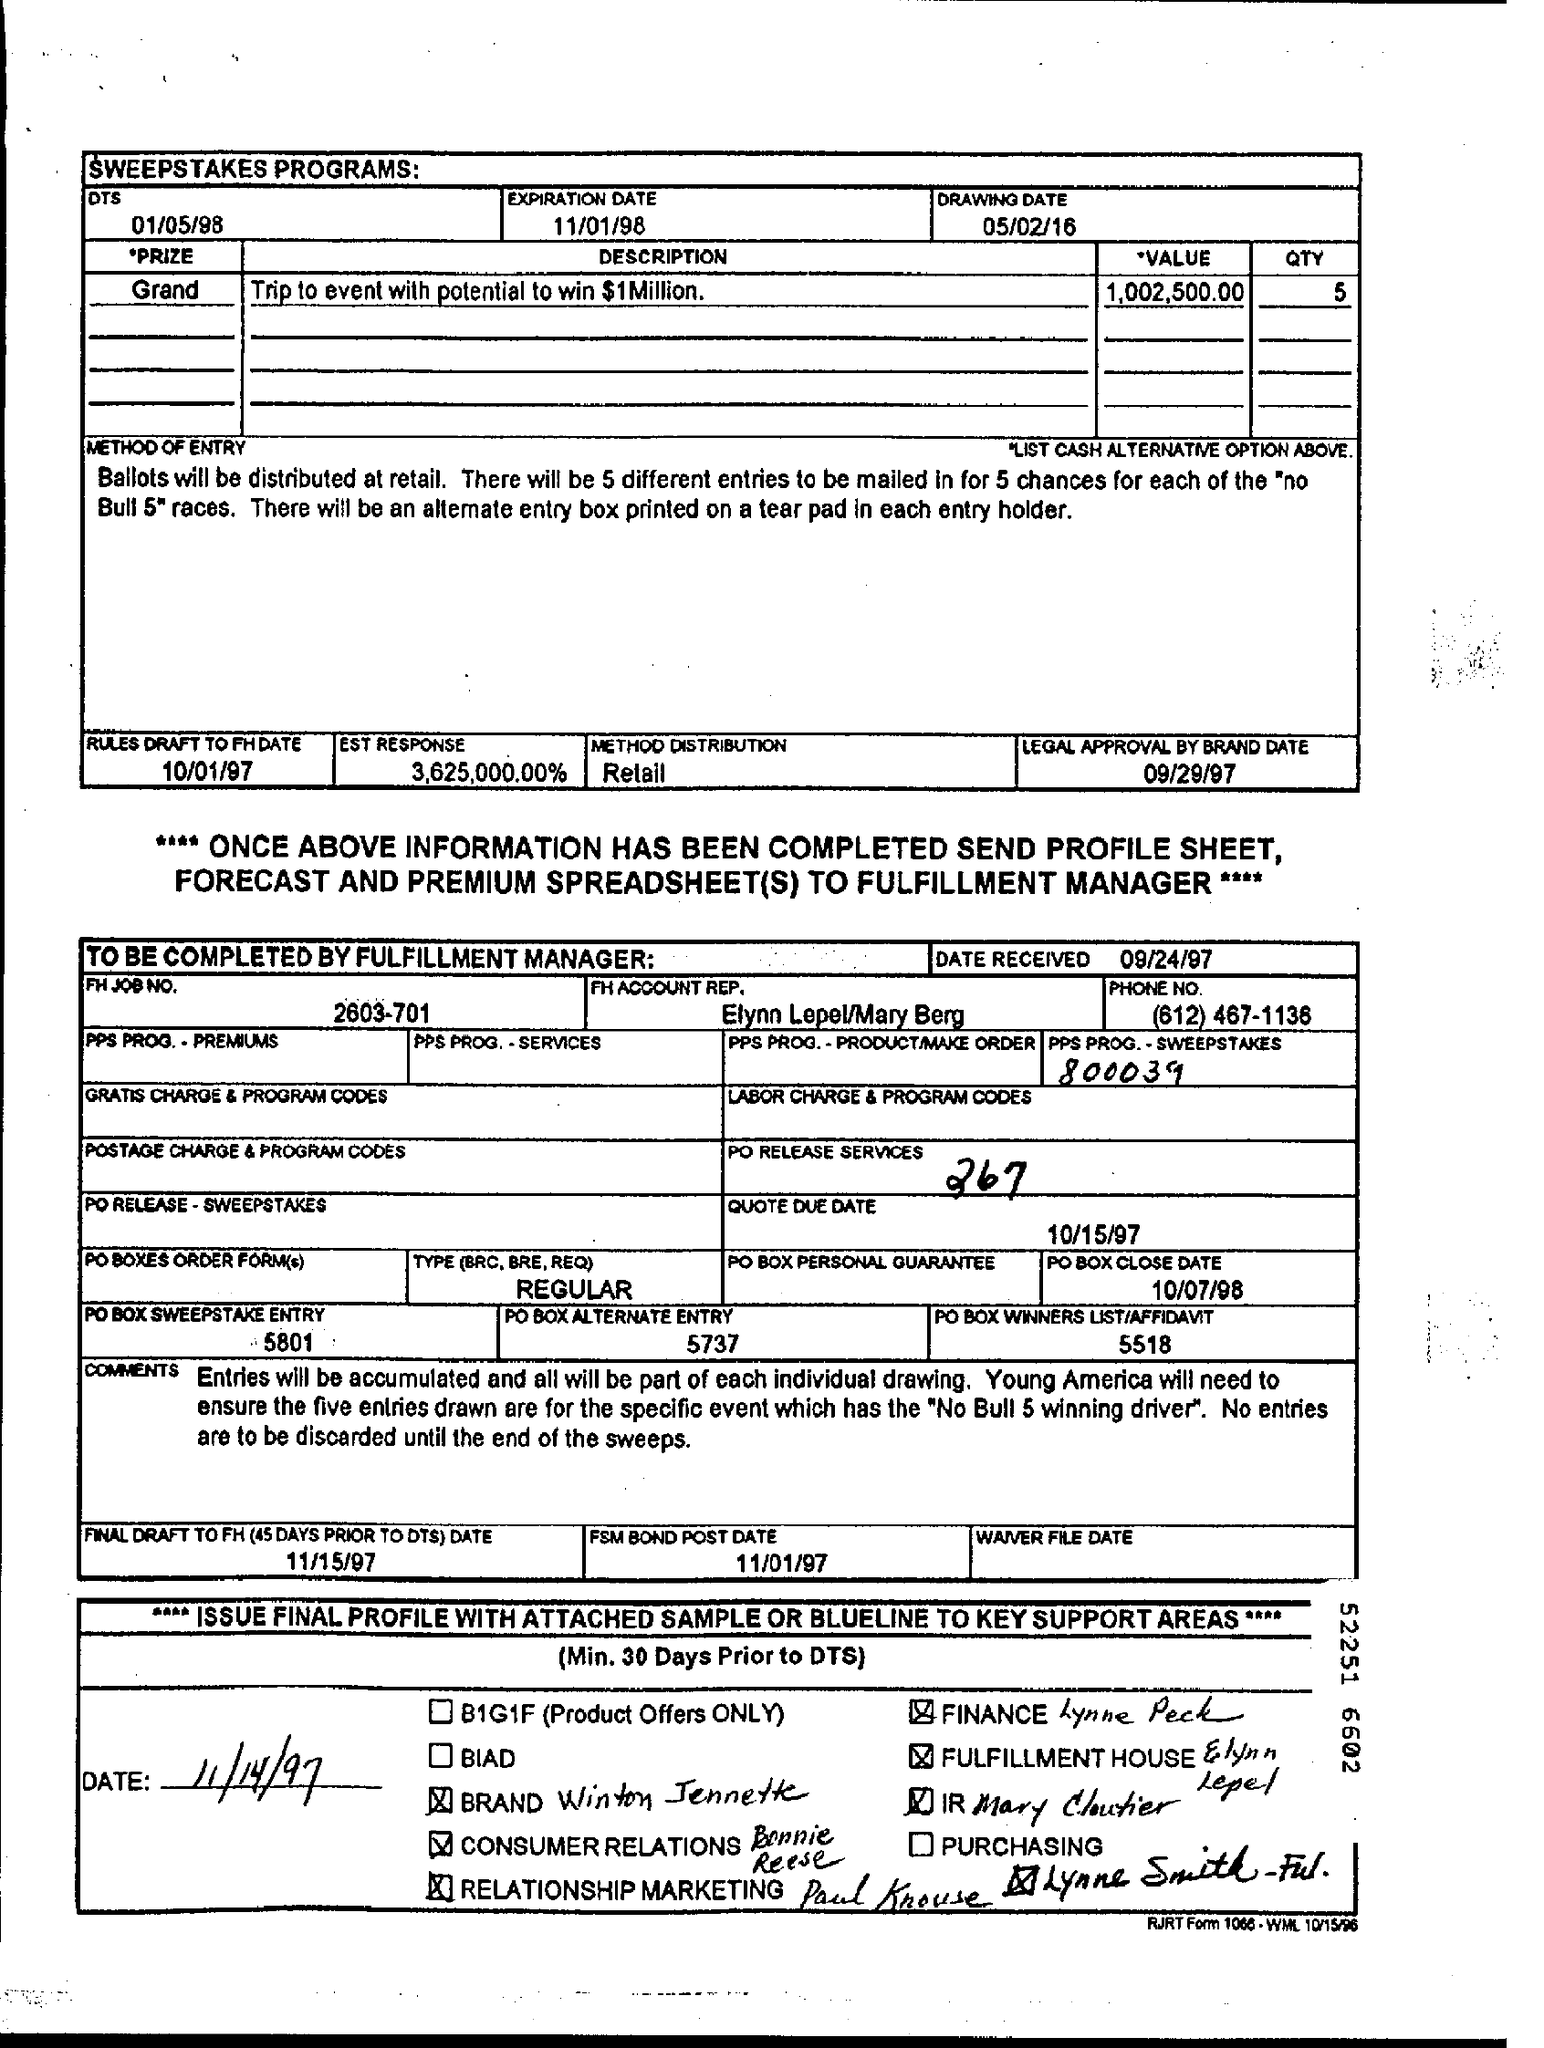Highlight a few significant elements in this photo. The expiration date is 11/01/98. The value of the prize is one million, two hundred and two thousand, five hundred and ten dollars and cents. The distribution method is a crucial aspect of retail, as it determines how products are made available to consumers and how they are marketed and sold. The drawing date for the sweepstakes programs is May 2nd, 2016. The prize description is a trip to an event with the potential to win one million dollars. 